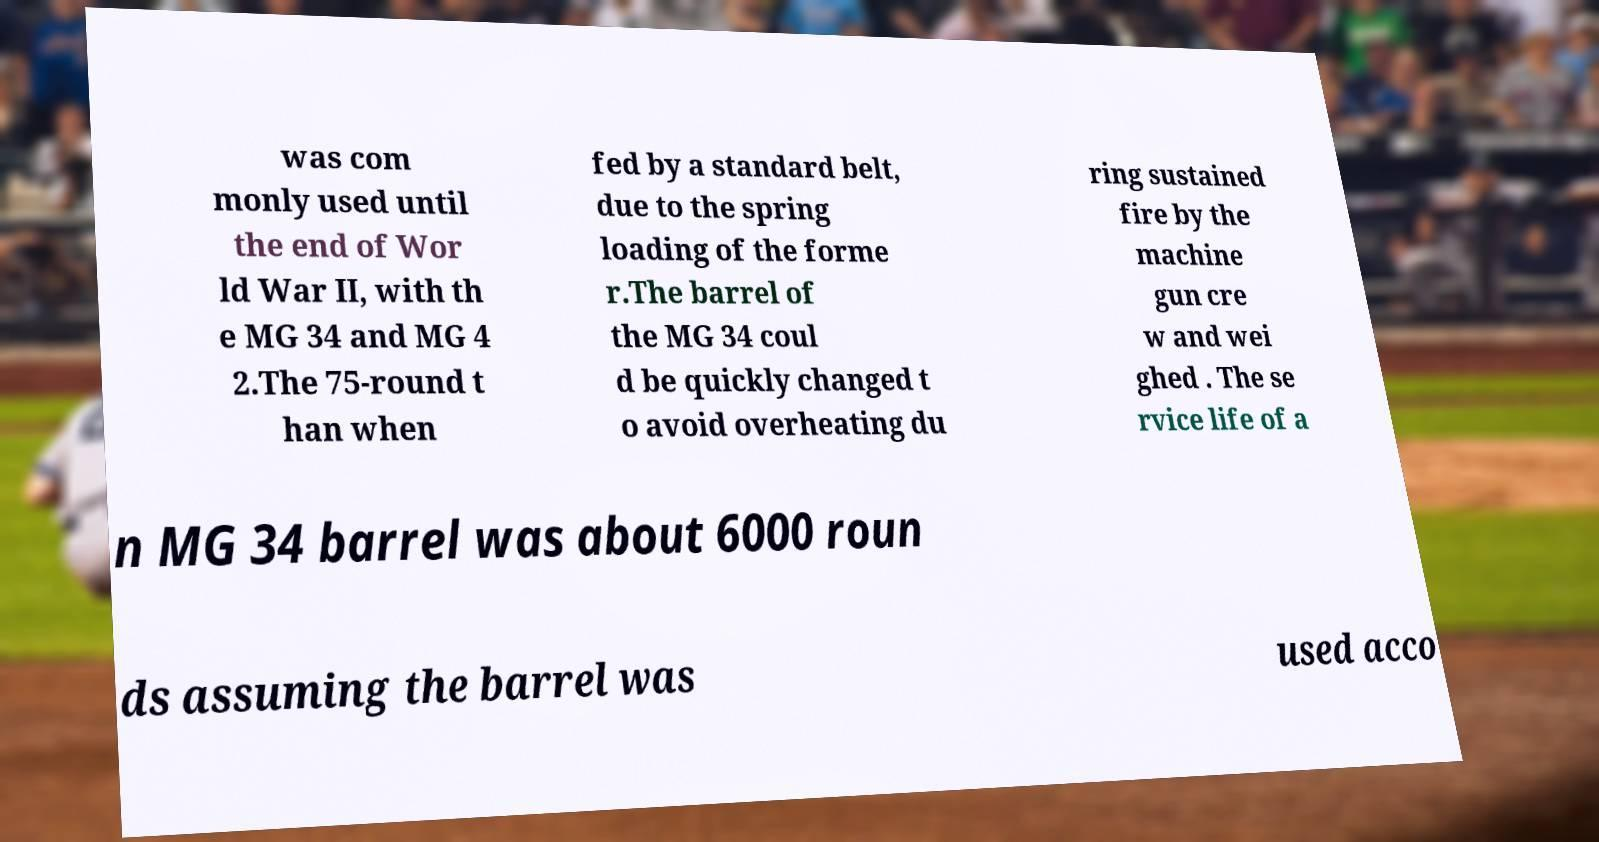What messages or text are displayed in this image? I need them in a readable, typed format. was com monly used until the end of Wor ld War II, with th e MG 34 and MG 4 2.The 75-round t han when fed by a standard belt, due to the spring loading of the forme r.The barrel of the MG 34 coul d be quickly changed t o avoid overheating du ring sustained fire by the machine gun cre w and wei ghed . The se rvice life of a n MG 34 barrel was about 6000 roun ds assuming the barrel was used acco 